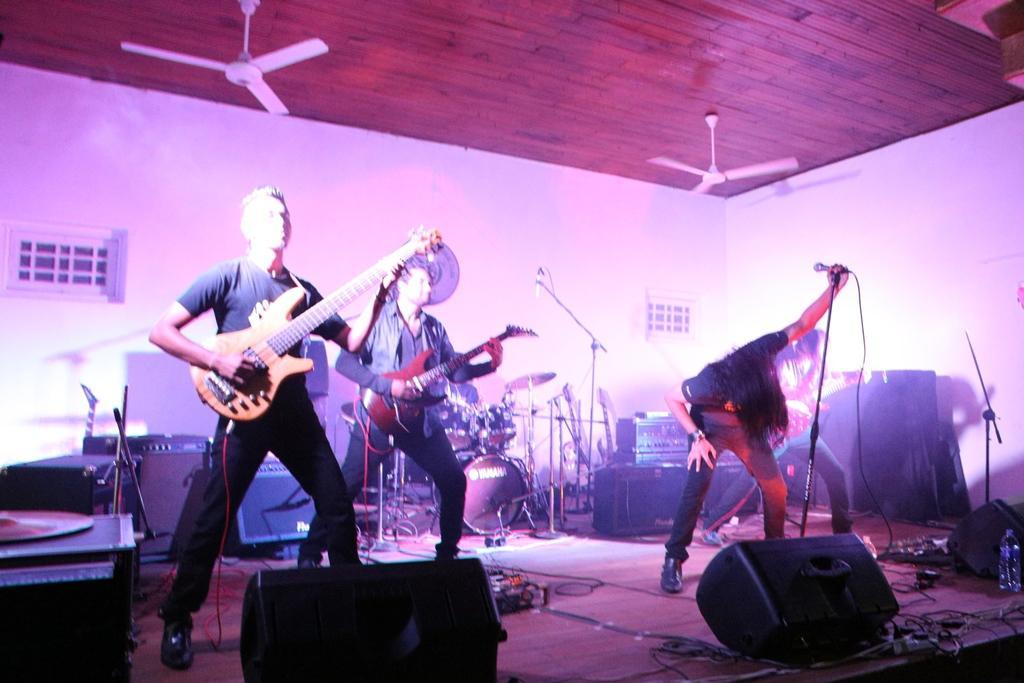Could you give a brief overview of what you see in this image? 2 people at the left are playing guitar. the person at the right is holding microphone and standing. behind them there are drums. behind that there is a white wall. on the roof there are 2 fans. 